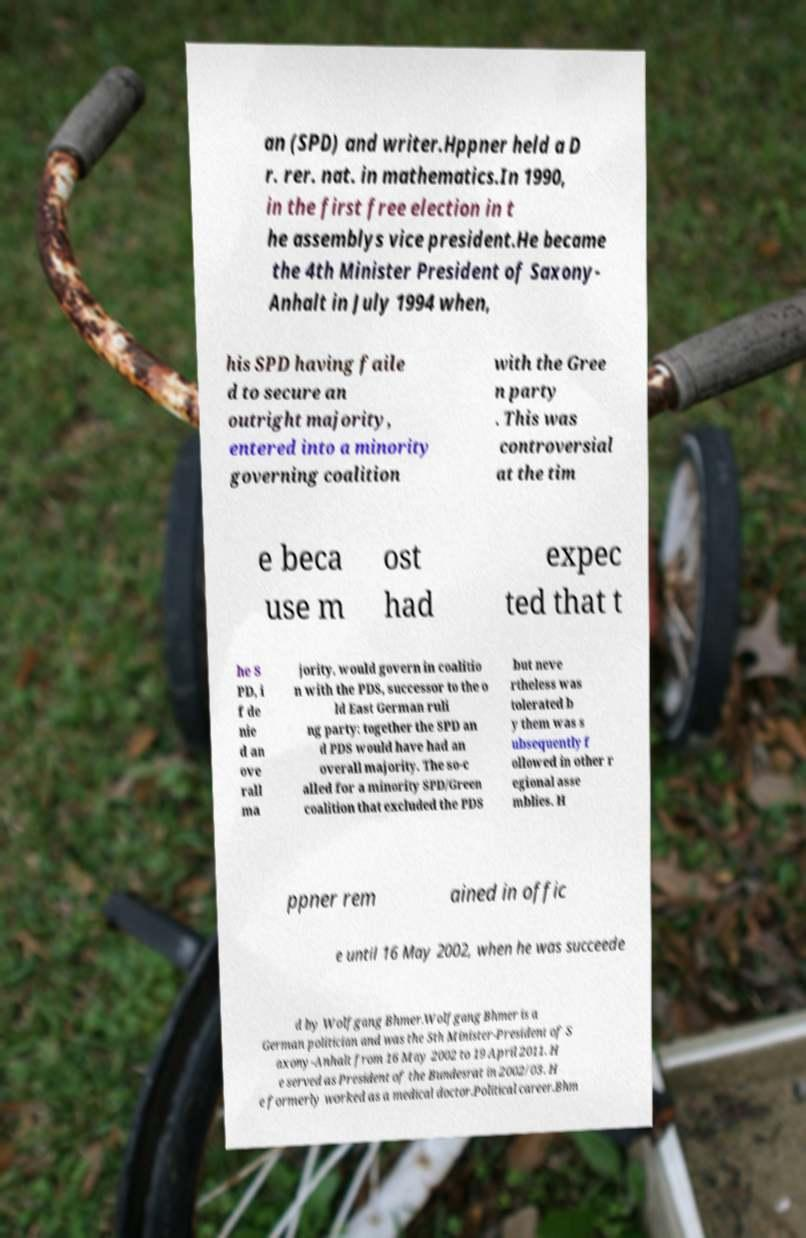There's text embedded in this image that I need extracted. Can you transcribe it verbatim? an (SPD) and writer.Hppner held a D r. rer. nat. in mathematics.In 1990, in the first free election in t he assemblys vice president.He became the 4th Minister President of Saxony- Anhalt in July 1994 when, his SPD having faile d to secure an outright majority, entered into a minority governing coalition with the Gree n party . This was controversial at the tim e beca use m ost had expec ted that t he S PD, i f de nie d an ove rall ma jority, would govern in coalitio n with the PDS, successor to the o ld East German ruli ng party: together the SPD an d PDS would have had an overall majority. The so-c alled for a minority SPD/Green coalition that excluded the PDS but neve rtheless was tolerated b y them was s ubsequently f ollowed in other r egional asse mblies. H ppner rem ained in offic e until 16 May 2002, when he was succeede d by Wolfgang Bhmer.Wolfgang Bhmer is a German politician and was the 5th Minister-President of S axony-Anhalt from 16 May 2002 to 19 April 2011. H e served as President of the Bundesrat in 2002/03. H e formerly worked as a medical doctor.Political career.Bhm 